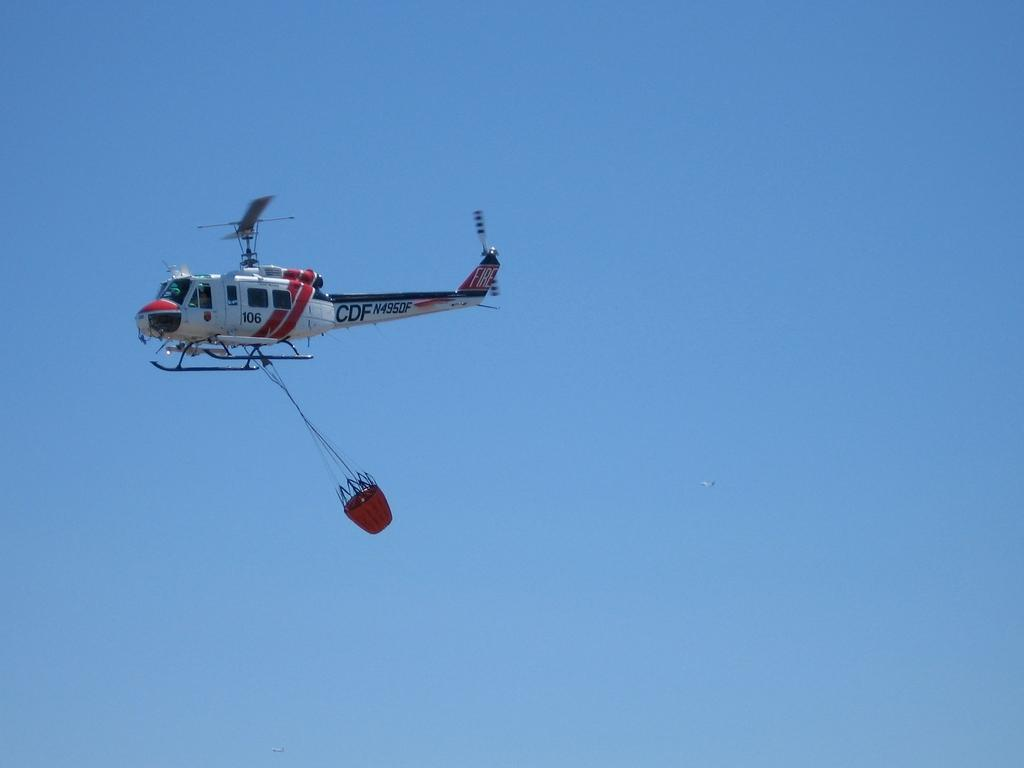What is the main subject in the center of the image? There is a helicopter in the center of the image. What can be seen in the background of the image? The sky is visible in the background of the image. What type of bait is being used to catch fish in the image? There is no mention of fish or bait in the image; it features a helicopter and the sky. What is the crack in the table in the image? There is no table or crack present in the image. 